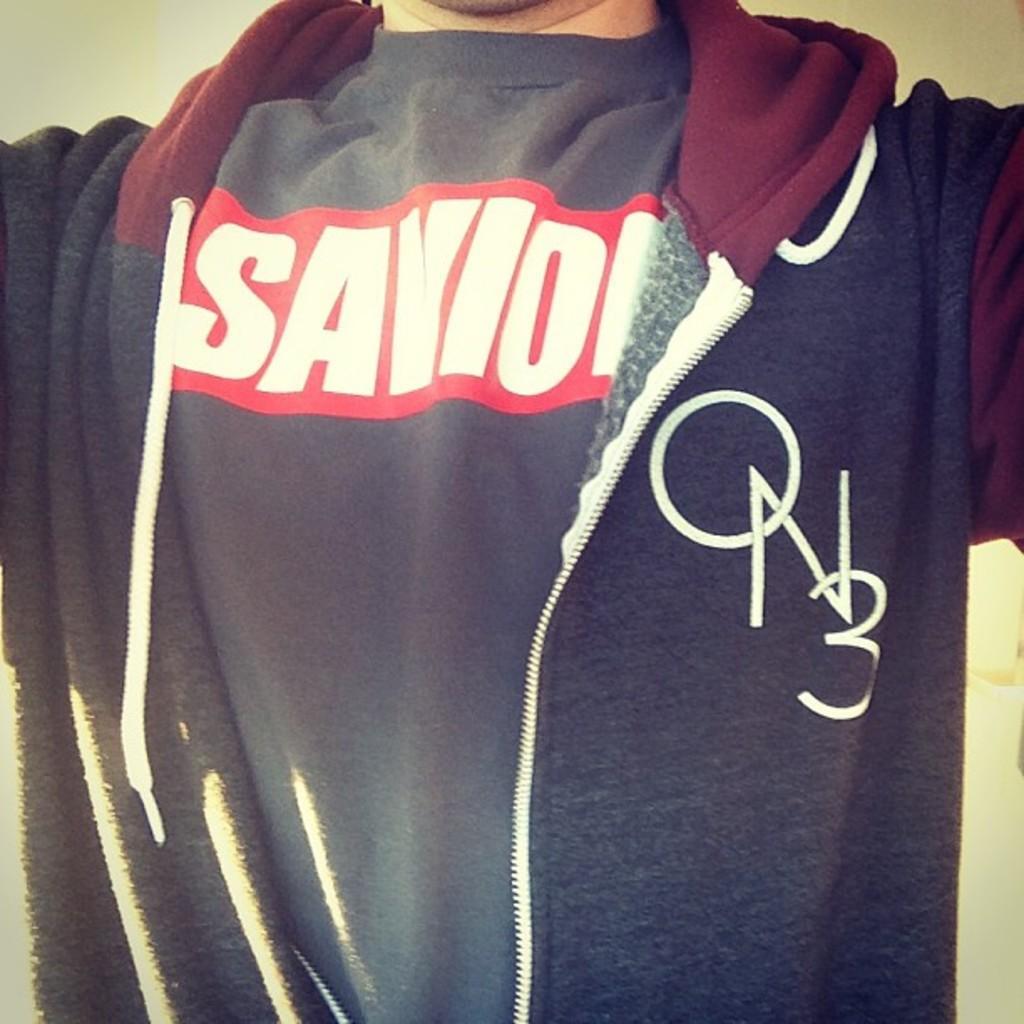Describe this image in one or two sentences. In this image we can see a person wearing the jacket. 